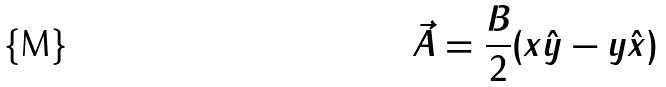<formula> <loc_0><loc_0><loc_500><loc_500>\vec { A } = \frac { B } { 2 } ( x \hat { y } - y \hat { x } )</formula> 